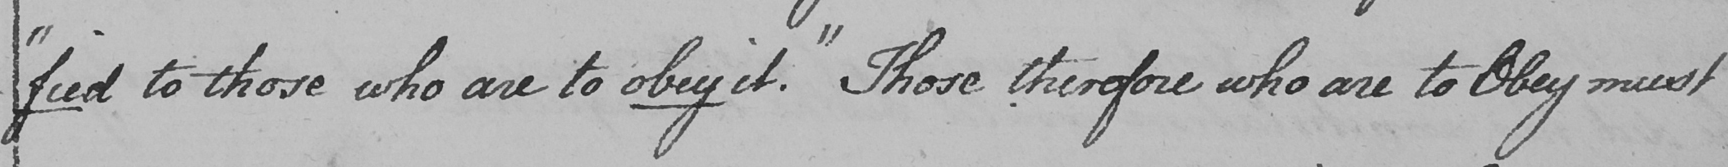What does this handwritten line say? -fied "  to those who are to obey it . "  Those therefore who are to Obey must 